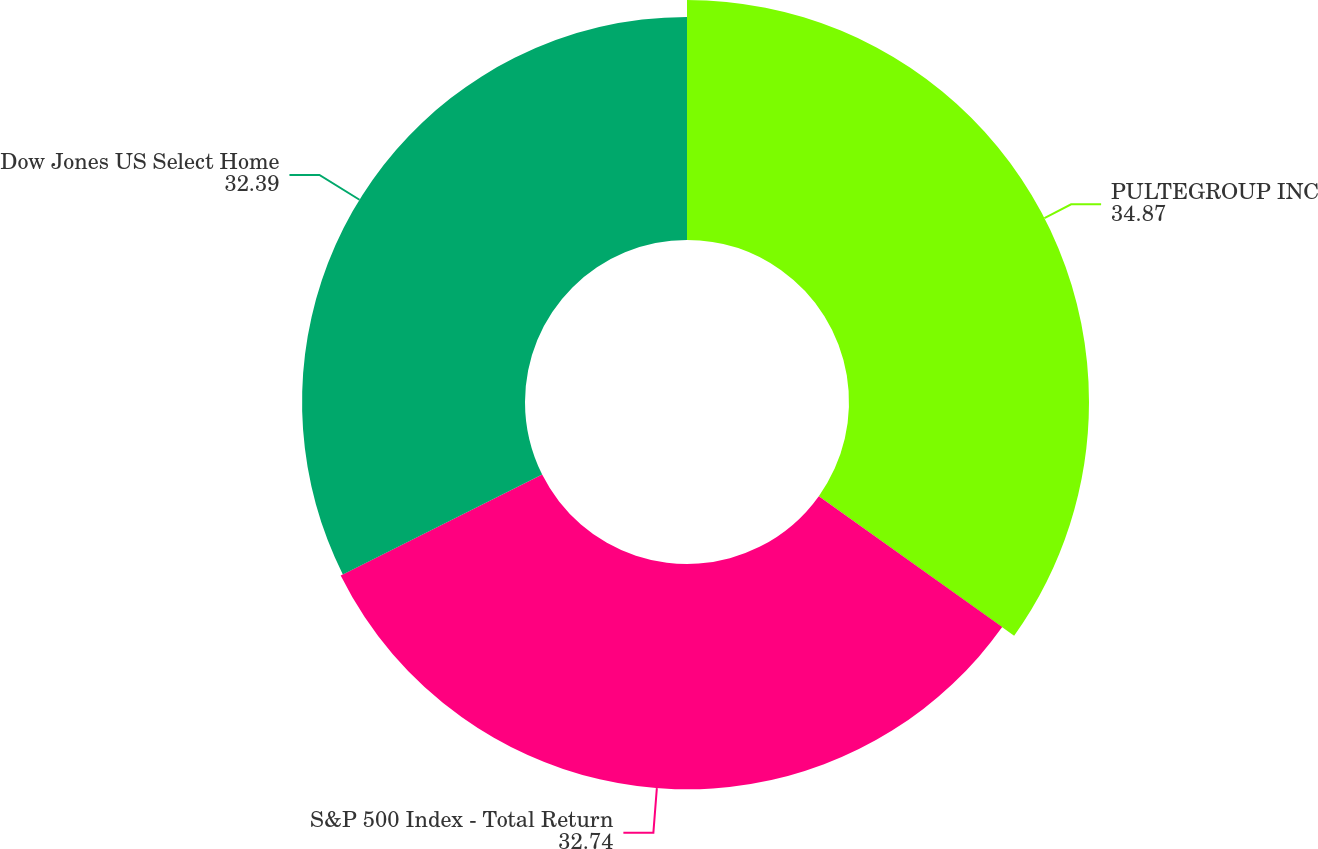Convert chart. <chart><loc_0><loc_0><loc_500><loc_500><pie_chart><fcel>PULTEGROUP INC<fcel>S&P 500 Index - Total Return<fcel>Dow Jones US Select Home<nl><fcel>34.87%<fcel>32.74%<fcel>32.39%<nl></chart> 